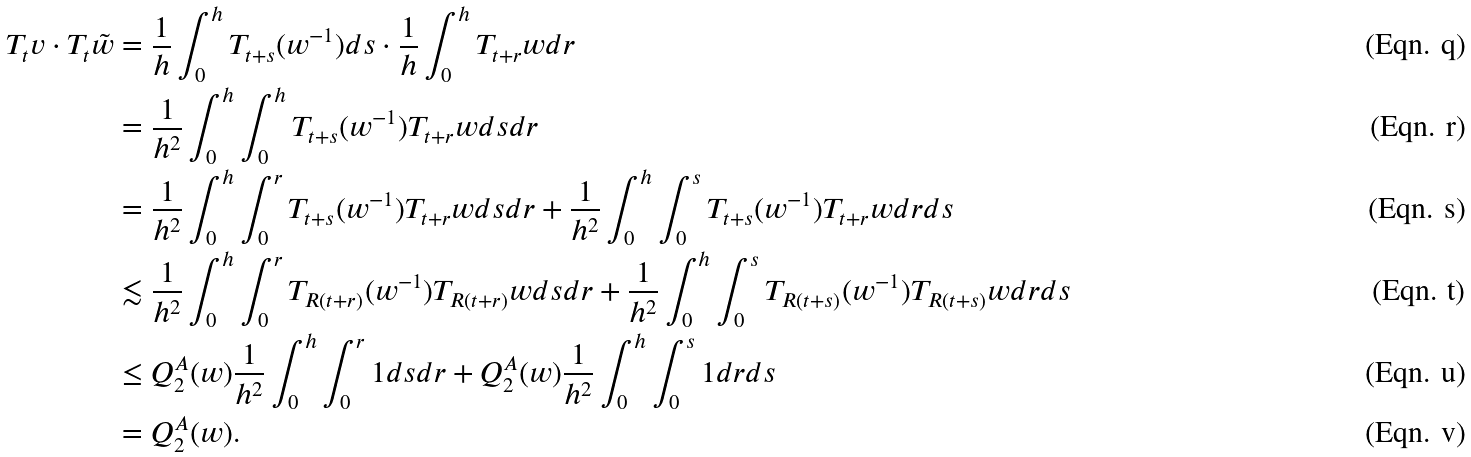Convert formula to latex. <formula><loc_0><loc_0><loc_500><loc_500>T _ { t } v \cdot T _ { t } \tilde { w } & = \frac { 1 } { h } \int _ { 0 } ^ { h } T _ { t + s } ( w ^ { - 1 } ) d s \cdot \frac { 1 } { h } \int _ { 0 } ^ { h } T _ { t + r } w d r \\ & = \frac { 1 } { h ^ { 2 } } \int _ { 0 } ^ { h } \int _ { 0 } ^ { h } T _ { t + s } ( w ^ { - 1 } ) T _ { t + r } w d s d r \\ & = \frac { 1 } { h ^ { 2 } } \int _ { 0 } ^ { h } \int _ { 0 } ^ { r } T _ { t + s } ( w ^ { - 1 } ) T _ { t + r } w d s d r + \frac { 1 } { h ^ { 2 } } \int _ { 0 } ^ { h } \int _ { 0 } ^ { s } T _ { t + s } ( w ^ { - 1 } ) T _ { t + r } w d r d s \\ & \lesssim \frac { 1 } { h ^ { 2 } } \int _ { 0 } ^ { h } \int _ { 0 } ^ { r } T _ { R ( t + r ) } ( w ^ { - 1 } ) T _ { R ( t + r ) } w d s d r + \frac { 1 } { h ^ { 2 } } \int _ { 0 } ^ { h } \int _ { 0 } ^ { s } T _ { R ( t + s ) } ( w ^ { - 1 } ) T _ { R ( t + s ) } w d r d s \\ & \leq Q ^ { A } _ { 2 } ( w ) \frac { 1 } { h ^ { 2 } } \int _ { 0 } ^ { h } \int _ { 0 } ^ { r } 1 d s d r + Q ^ { A } _ { 2 } ( w ) \frac { 1 } { h ^ { 2 } } \int _ { 0 } ^ { h } \int _ { 0 } ^ { s } 1 d r d s \\ & = Q ^ { A } _ { 2 } ( w ) .</formula> 